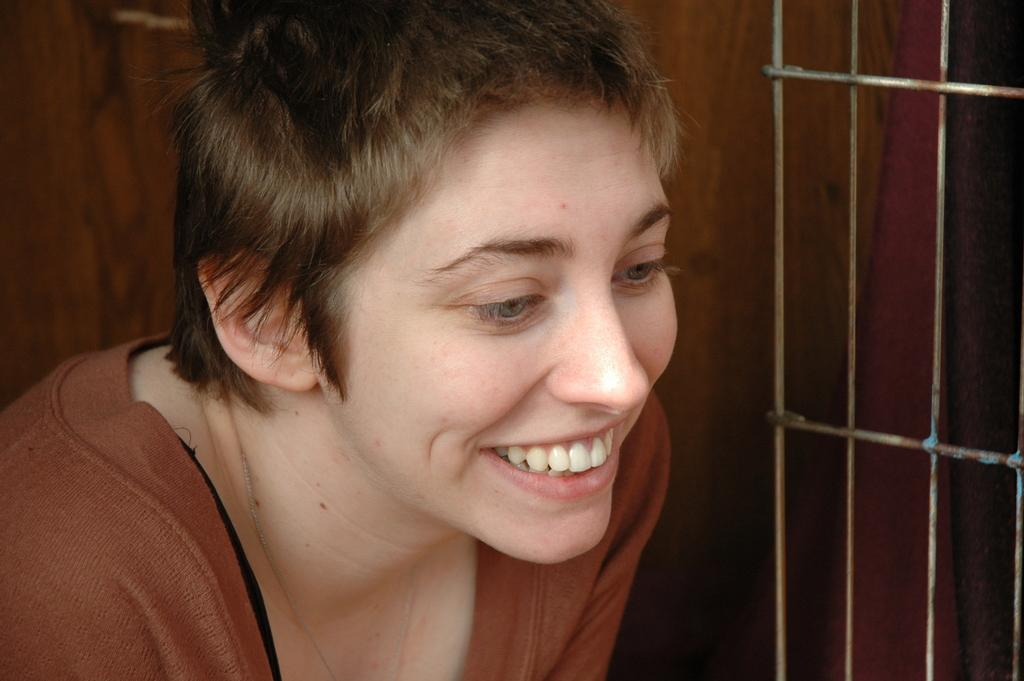Who is present in the image? There is a woman in the image. What is the woman doing in the image? The woman is smiling in the image. What is the woman wearing in the image? The woman is wearing a brown color t-shirt in the image. What type of mint is growing in the woman's t-shirt in the image? There is no mint or any plants visible in the image, and the woman is wearing a brown color t-shirt. 